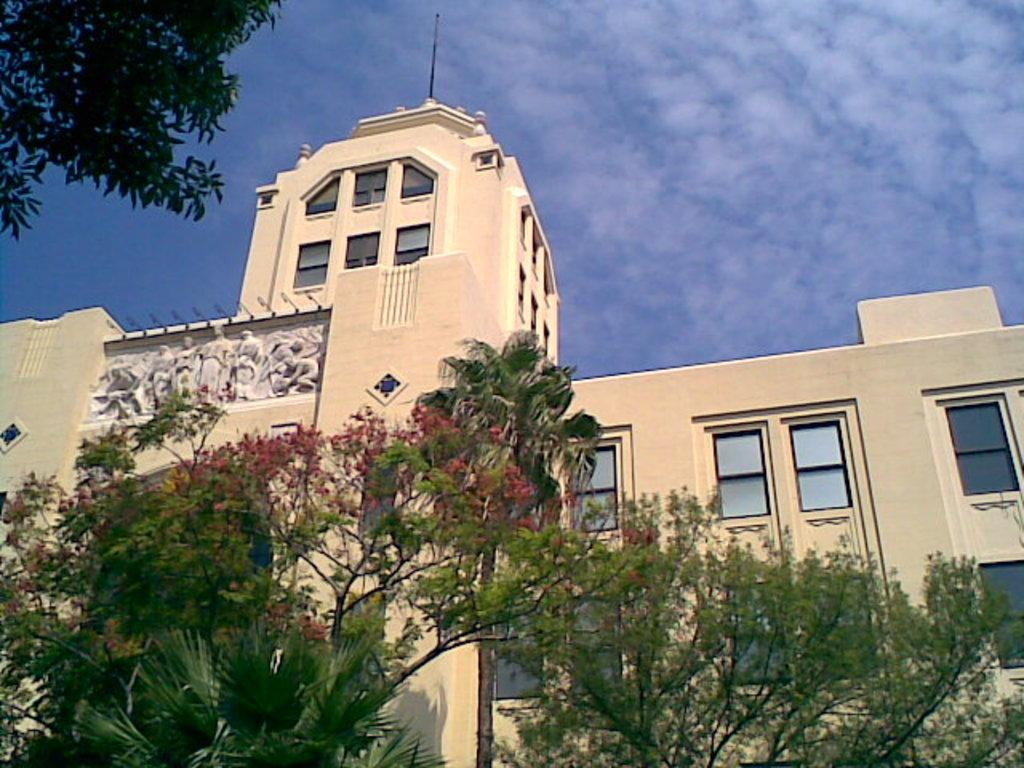What type of vegetation is visible in the image? There are trees in the image. What type of structure can be seen in the image? There is a building with windows in the image. What is visible in the background of the image? The sky is visible in the background of the image. What type of pen can be seen being used to draw on the texture of the boot in the image? There is no pen, texture, or boot present in the image. 